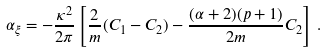<formula> <loc_0><loc_0><loc_500><loc_500>\alpha _ { \xi } = - \frac { \kappa ^ { 2 } } { 2 \pi } \left [ \frac { 2 } { m } ( C _ { 1 } - C _ { 2 } ) - \frac { ( \alpha + 2 ) ( p + 1 ) } { 2 m } C _ { 2 } \right ] \, .</formula> 